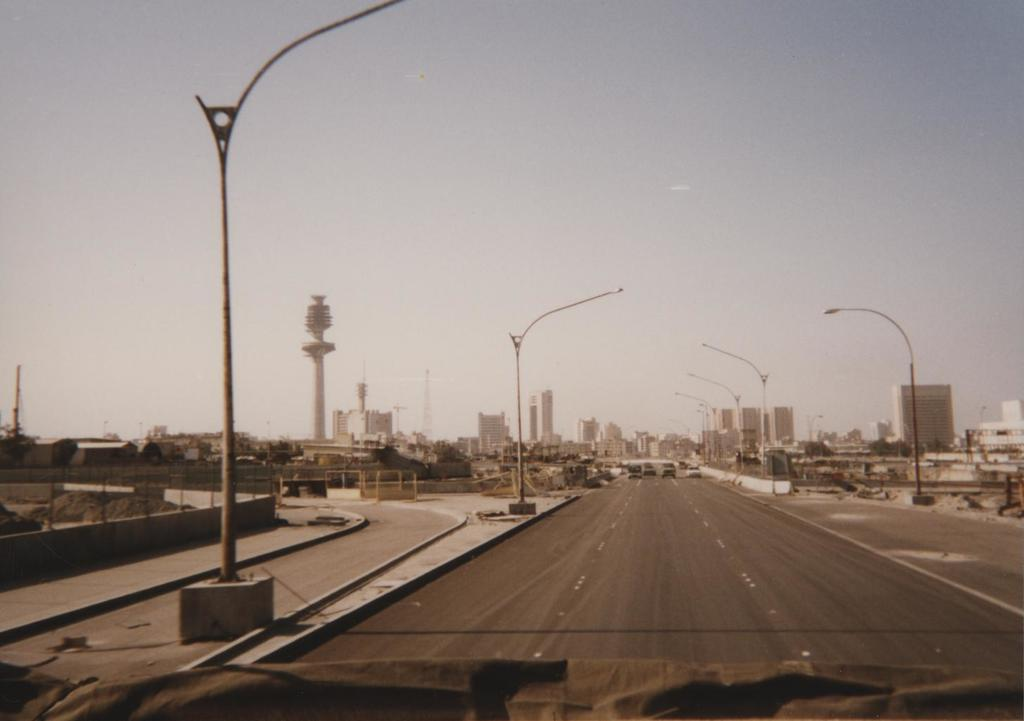What is the main feature of the image? There is a road in the image. What can be seen on the road? There are vehicles on the road. What structures are present alongside the road? There are even light poles in the image. What else is visible in the image? There are buildings in the image. What can be seen above the road and buildings? The sky is visible in the image. Can you tell me how many credit cards are visible in the image? There are no credit cards present in the image. What type of vein is visible in the image? There is no vein visible in the image. 